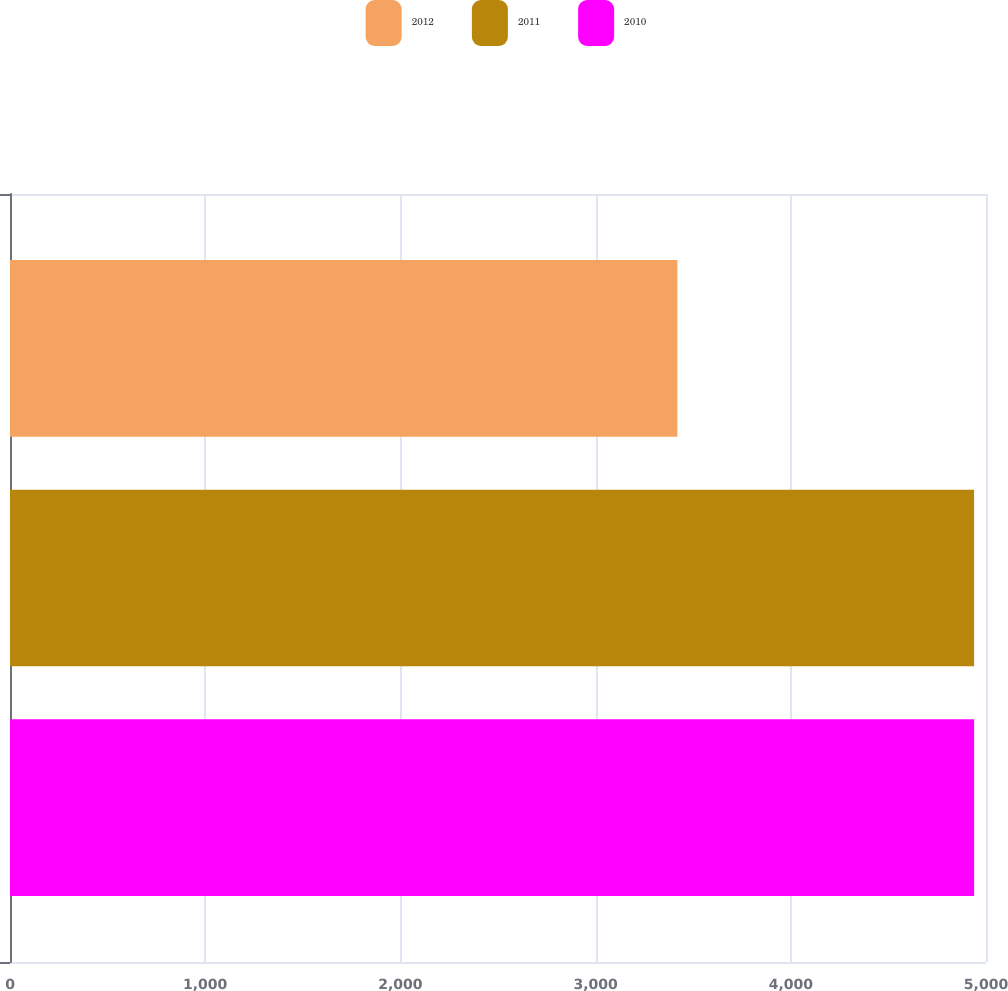Convert chart to OTSL. <chart><loc_0><loc_0><loc_500><loc_500><stacked_bar_chart><ecel><fcel>Unnamed: 1<nl><fcel>2012<fcel>3419<nl><fcel>2011<fcel>4939<nl><fcel>2010<fcel>4939<nl></chart> 